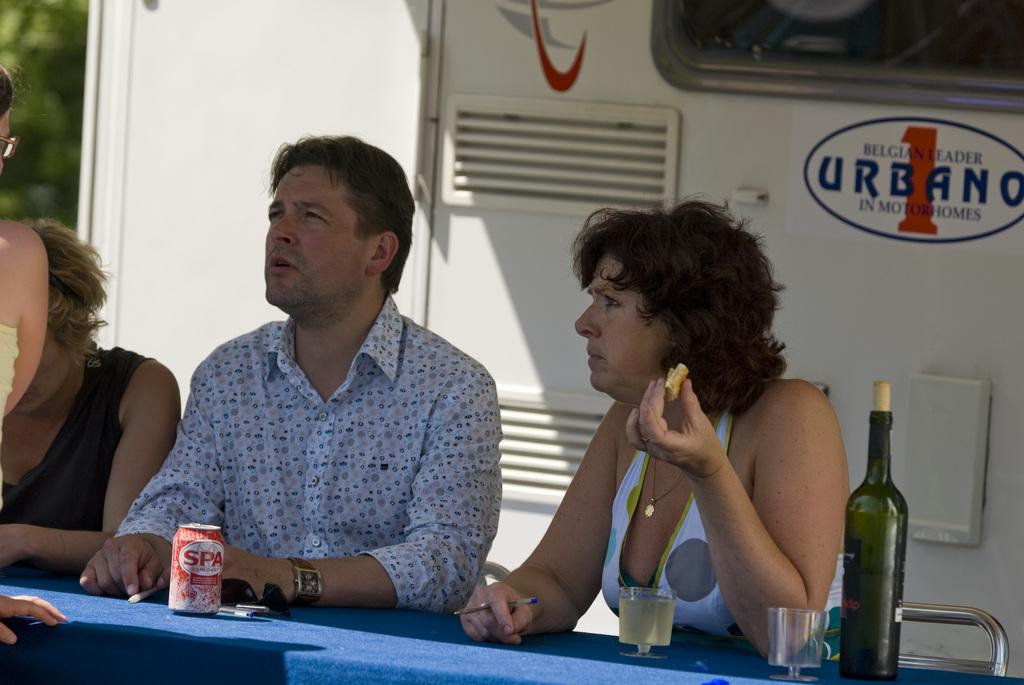How many people are in the image? There are three people in the image. What are the people doing in the image? The people are sitting on chairs. What is present on the table in the image? There is a bottle, glasses, and a tin on the table. What type of class is being held in the image? There is no indication of a class being held in the image. What level of wealth can be determined from the image? The image does not provide any information about the wealth of the people or the setting. 